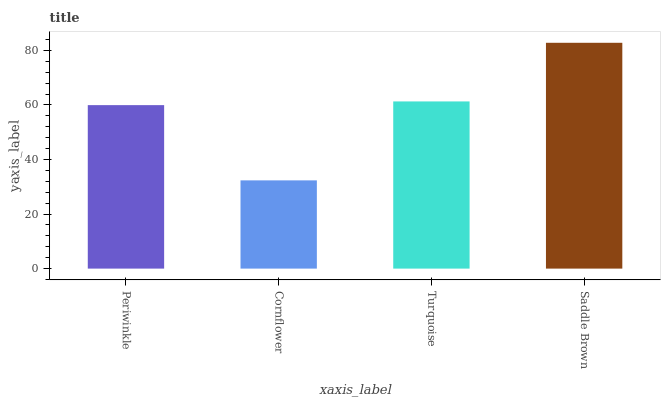Is Cornflower the minimum?
Answer yes or no. Yes. Is Saddle Brown the maximum?
Answer yes or no. Yes. Is Turquoise the minimum?
Answer yes or no. No. Is Turquoise the maximum?
Answer yes or no. No. Is Turquoise greater than Cornflower?
Answer yes or no. Yes. Is Cornflower less than Turquoise?
Answer yes or no. Yes. Is Cornflower greater than Turquoise?
Answer yes or no. No. Is Turquoise less than Cornflower?
Answer yes or no. No. Is Turquoise the high median?
Answer yes or no. Yes. Is Periwinkle the low median?
Answer yes or no. Yes. Is Periwinkle the high median?
Answer yes or no. No. Is Saddle Brown the low median?
Answer yes or no. No. 